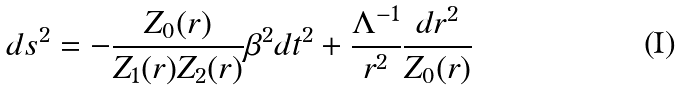Convert formula to latex. <formula><loc_0><loc_0><loc_500><loc_500>d s ^ { 2 } = - \frac { Z _ { 0 } ( r ) } { Z _ { 1 } ( r ) Z _ { 2 } ( r ) } \beta ^ { 2 } d t ^ { 2 } + \frac { \Lambda ^ { - 1 } } { r ^ { 2 } } \frac { d r ^ { 2 } } { Z _ { 0 } ( r ) }</formula> 